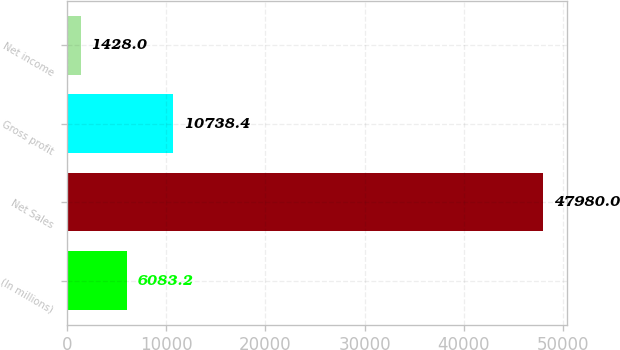Convert chart. <chart><loc_0><loc_0><loc_500><loc_500><bar_chart><fcel>(In millions)<fcel>Net Sales<fcel>Gross profit<fcel>Net income<nl><fcel>6083.2<fcel>47980<fcel>10738.4<fcel>1428<nl></chart> 